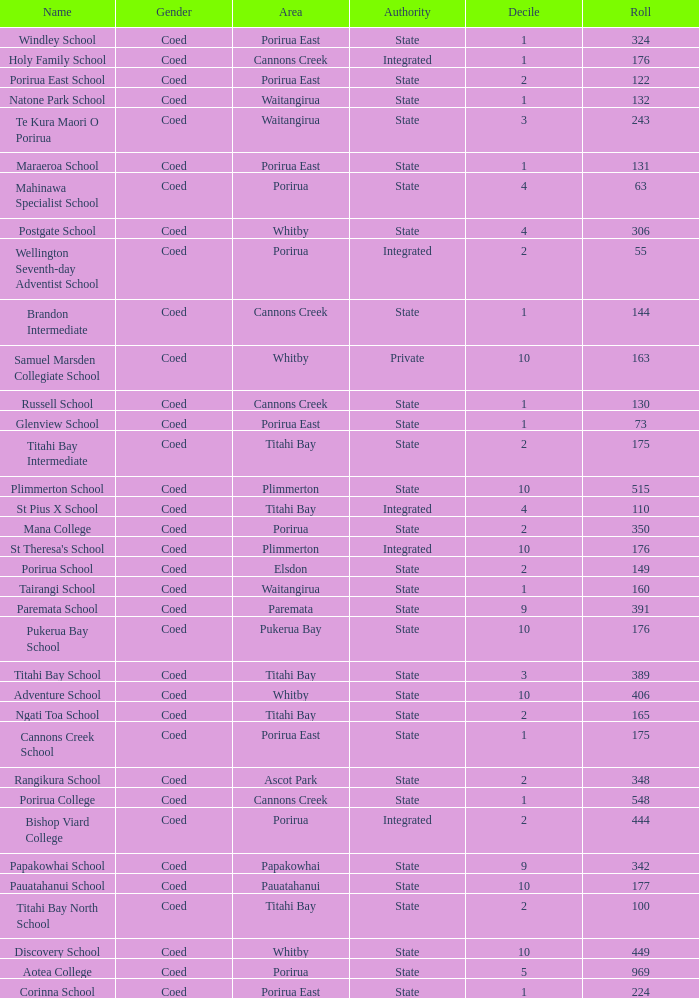What is the roll of Bishop Viard College (An Integrated College), which has a decile larger than 1? 1.0. 